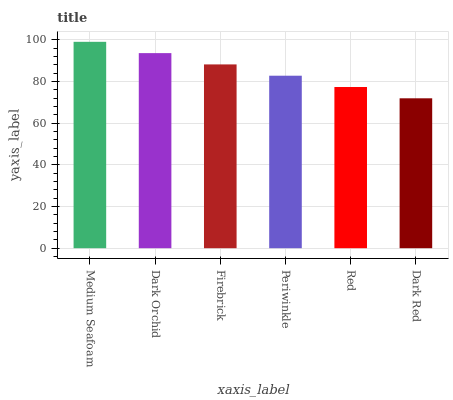Is Dark Red the minimum?
Answer yes or no. Yes. Is Medium Seafoam the maximum?
Answer yes or no. Yes. Is Dark Orchid the minimum?
Answer yes or no. No. Is Dark Orchid the maximum?
Answer yes or no. No. Is Medium Seafoam greater than Dark Orchid?
Answer yes or no. Yes. Is Dark Orchid less than Medium Seafoam?
Answer yes or no. Yes. Is Dark Orchid greater than Medium Seafoam?
Answer yes or no. No. Is Medium Seafoam less than Dark Orchid?
Answer yes or no. No. Is Firebrick the high median?
Answer yes or no. Yes. Is Periwinkle the low median?
Answer yes or no. Yes. Is Dark Red the high median?
Answer yes or no. No. Is Red the low median?
Answer yes or no. No. 